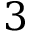<formula> <loc_0><loc_0><loc_500><loc_500>3</formula> 